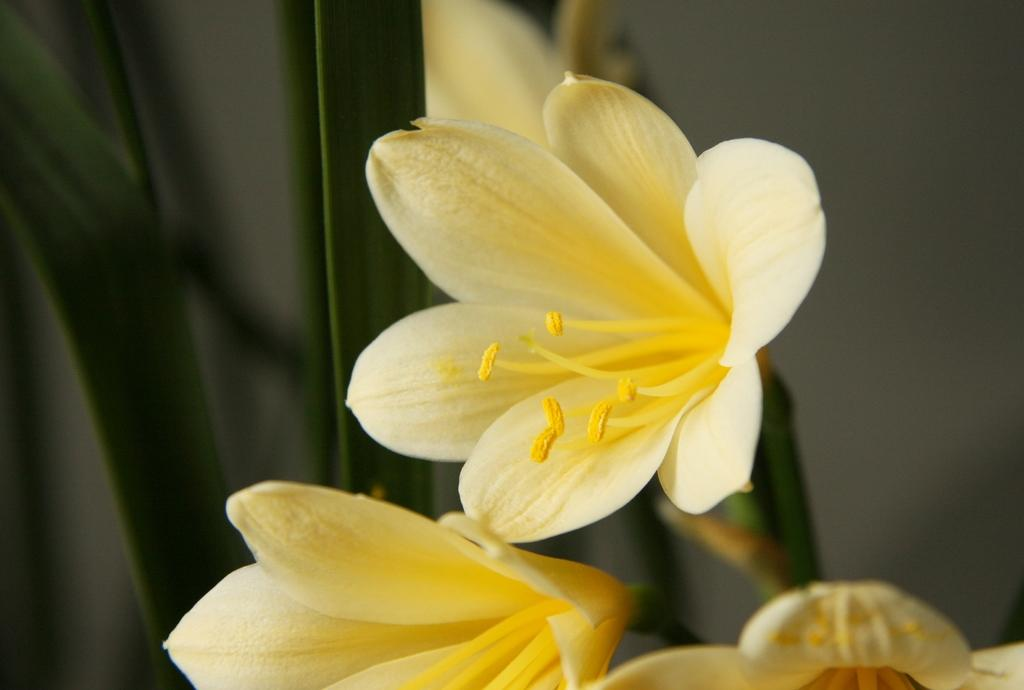What type of flowers are in the middle of the picture? There are yellow color flowers in the middle of the picture. Can you describe the background of the image? The background of the image is blurred. How many babies are present in the image? There are no babies present in the image; it features yellow color flowers in the middle of the picture. What type of destruction can be seen in the image? There is no destruction present in the image; it features yellow color flowers in the middle of the picture with a blurred background. 